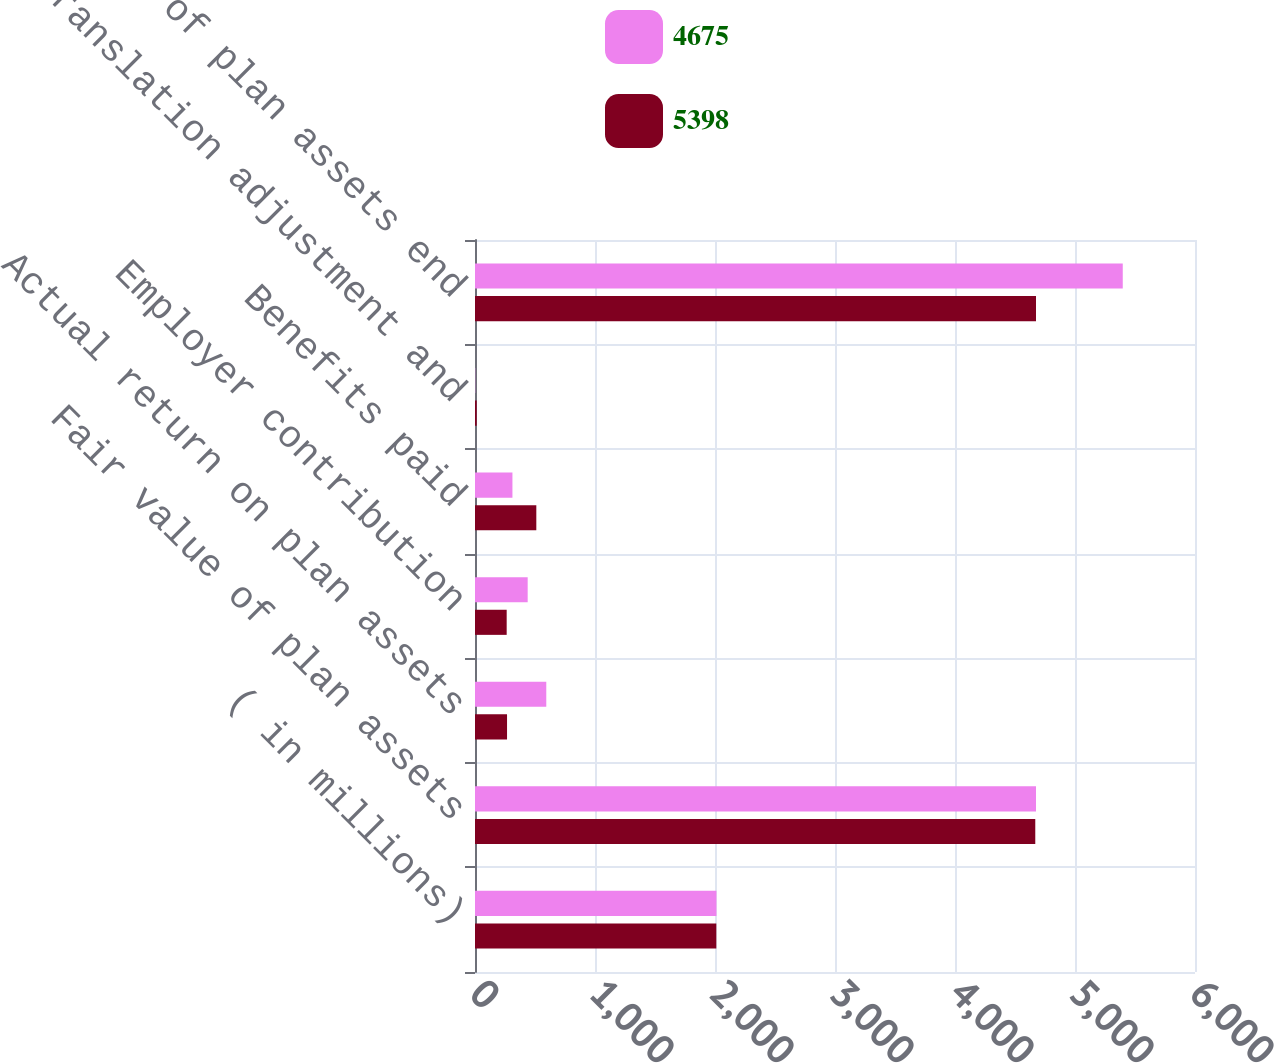Convert chart to OTSL. <chart><loc_0><loc_0><loc_500><loc_500><stacked_bar_chart><ecel><fcel>( in millions)<fcel>Fair value of plan assets<fcel>Actual return on plan assets<fcel>Employer contribution<fcel>Benefits paid<fcel>Translation adjustment and<fcel>Fair value of plan assets end<nl><fcel>4675<fcel>2012<fcel>4675<fcel>594<fcel>439<fcel>312<fcel>2<fcel>5398<nl><fcel>5398<fcel>2011<fcel>4669<fcel>267<fcel>264<fcel>511<fcel>14<fcel>4675<nl></chart> 